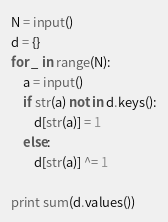Convert code to text. <code><loc_0><loc_0><loc_500><loc_500><_Python_>N = input()
d = {}
for _ in range(N):
    a = input()
    if str(a) not in d.keys():
        d[str(a)] = 1
    else:
        d[str(a)] ^= 1

print sum(d.values())</code> 